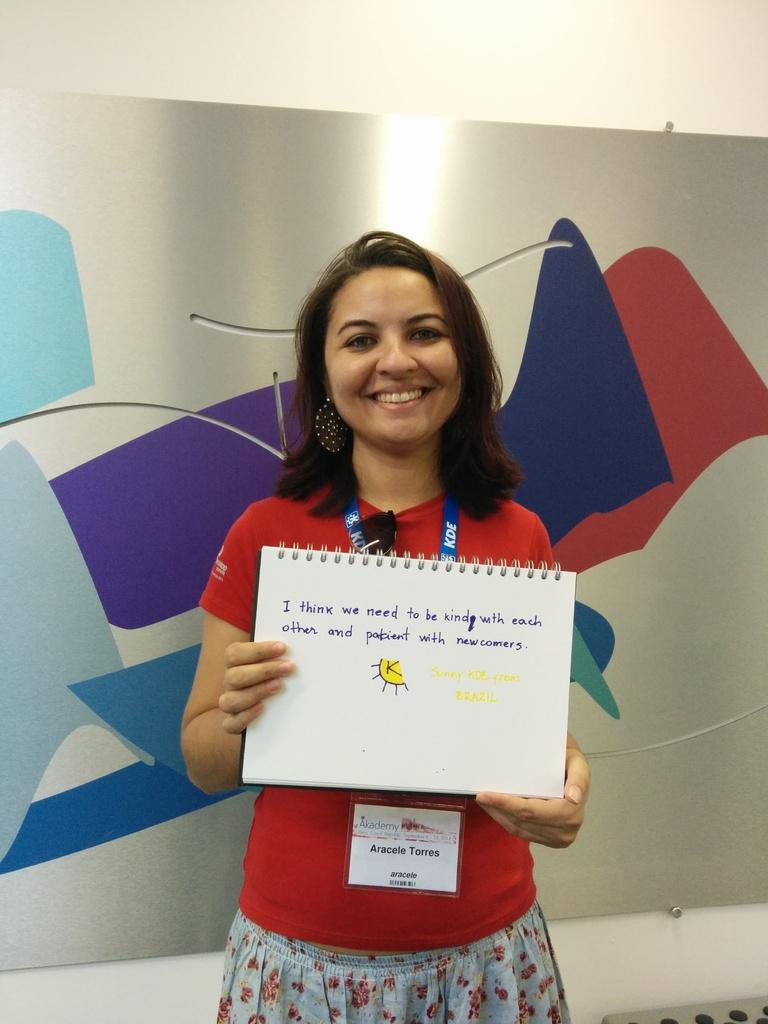Who is present in the image? There is a woman in the picture. What is the woman doing in the image? The woman is standing. What is the woman holding in the image? The woman is holding a book. What can be seen on the book? The book has something written on it. What else can be seen in the background of the image? There are other objects in the background of the image. What type of smile can be seen on the woman's face in the image? There is no smile visible on the woman's face in the image. 